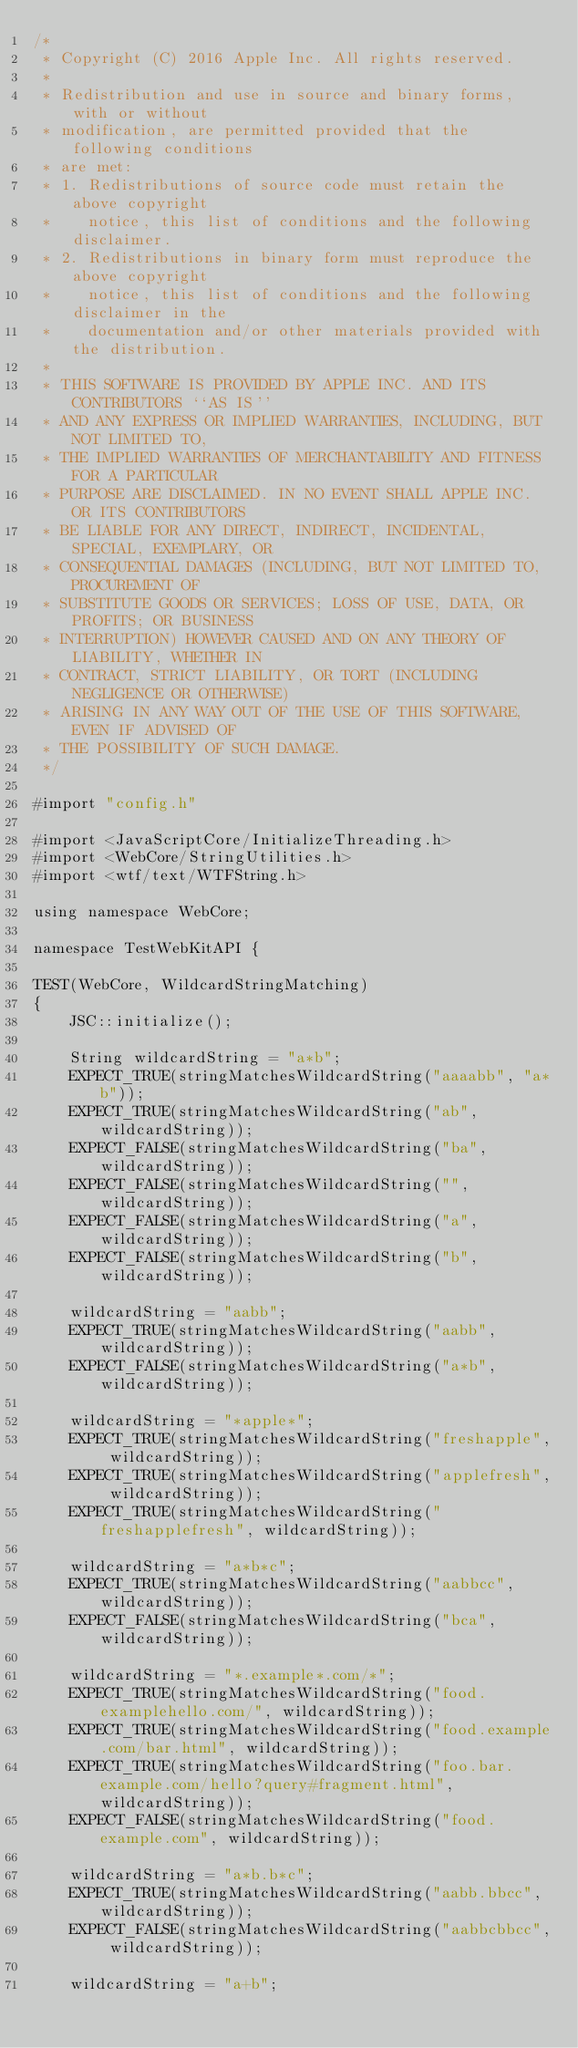Convert code to text. <code><loc_0><loc_0><loc_500><loc_500><_ObjectiveC_>/*
 * Copyright (C) 2016 Apple Inc. All rights reserved.
 *
 * Redistribution and use in source and binary forms, with or without
 * modification, are permitted provided that the following conditions
 * are met:
 * 1. Redistributions of source code must retain the above copyright
 *    notice, this list of conditions and the following disclaimer.
 * 2. Redistributions in binary form must reproduce the above copyright
 *    notice, this list of conditions and the following disclaimer in the
 *    documentation and/or other materials provided with the distribution.
 *
 * THIS SOFTWARE IS PROVIDED BY APPLE INC. AND ITS CONTRIBUTORS ``AS IS''
 * AND ANY EXPRESS OR IMPLIED WARRANTIES, INCLUDING, BUT NOT LIMITED TO,
 * THE IMPLIED WARRANTIES OF MERCHANTABILITY AND FITNESS FOR A PARTICULAR
 * PURPOSE ARE DISCLAIMED. IN NO EVENT SHALL APPLE INC. OR ITS CONTRIBUTORS
 * BE LIABLE FOR ANY DIRECT, INDIRECT, INCIDENTAL, SPECIAL, EXEMPLARY, OR
 * CONSEQUENTIAL DAMAGES (INCLUDING, BUT NOT LIMITED TO, PROCUREMENT OF
 * SUBSTITUTE GOODS OR SERVICES; LOSS OF USE, DATA, OR PROFITS; OR BUSINESS
 * INTERRUPTION) HOWEVER CAUSED AND ON ANY THEORY OF LIABILITY, WHETHER IN
 * CONTRACT, STRICT LIABILITY, OR TORT (INCLUDING NEGLIGENCE OR OTHERWISE)
 * ARISING IN ANY WAY OUT OF THE USE OF THIS SOFTWARE, EVEN IF ADVISED OF
 * THE POSSIBILITY OF SUCH DAMAGE.
 */

#import "config.h"

#import <JavaScriptCore/InitializeThreading.h>
#import <WebCore/StringUtilities.h>
#import <wtf/text/WTFString.h>

using namespace WebCore;

namespace TestWebKitAPI {

TEST(WebCore, WildcardStringMatching)
{
    JSC::initialize();

    String wildcardString = "a*b";
    EXPECT_TRUE(stringMatchesWildcardString("aaaabb", "a*b"));
    EXPECT_TRUE(stringMatchesWildcardString("ab", wildcardString));
    EXPECT_FALSE(stringMatchesWildcardString("ba", wildcardString));
    EXPECT_FALSE(stringMatchesWildcardString("", wildcardString));
    EXPECT_FALSE(stringMatchesWildcardString("a", wildcardString));
    EXPECT_FALSE(stringMatchesWildcardString("b", wildcardString));

    wildcardString = "aabb";
    EXPECT_TRUE(stringMatchesWildcardString("aabb", wildcardString));
    EXPECT_FALSE(stringMatchesWildcardString("a*b", wildcardString));

    wildcardString = "*apple*";
    EXPECT_TRUE(stringMatchesWildcardString("freshapple", wildcardString));
    EXPECT_TRUE(stringMatchesWildcardString("applefresh", wildcardString));
    EXPECT_TRUE(stringMatchesWildcardString("freshapplefresh", wildcardString));

    wildcardString = "a*b*c";
    EXPECT_TRUE(stringMatchesWildcardString("aabbcc", wildcardString));
    EXPECT_FALSE(stringMatchesWildcardString("bca", wildcardString));

    wildcardString = "*.example*.com/*";
    EXPECT_TRUE(stringMatchesWildcardString("food.examplehello.com/", wildcardString));
    EXPECT_TRUE(stringMatchesWildcardString("food.example.com/bar.html", wildcardString));
    EXPECT_TRUE(stringMatchesWildcardString("foo.bar.example.com/hello?query#fragment.html", wildcardString));
    EXPECT_FALSE(stringMatchesWildcardString("food.example.com", wildcardString));

    wildcardString = "a*b.b*c";
    EXPECT_TRUE(stringMatchesWildcardString("aabb.bbcc", wildcardString));
    EXPECT_FALSE(stringMatchesWildcardString("aabbcbbcc", wildcardString));

    wildcardString = "a+b";</code> 